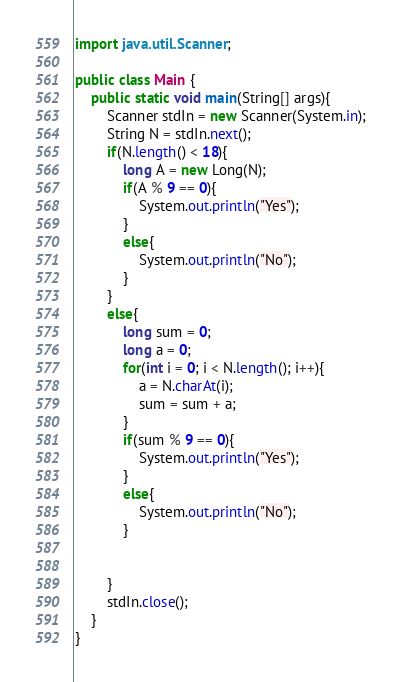Convert code to text. <code><loc_0><loc_0><loc_500><loc_500><_Java_>import java.util.Scanner;

public class Main {
	public static void main(String[] args){
		Scanner stdIn = new Scanner(System.in);
		String N = stdIn.next();
		if(N.length() < 18){
			long A = new Long(N);
			if(A % 9 == 0){
				System.out.println("Yes");
			}
			else{
				System.out.println("No");
			}
		}
		else{
			long sum = 0;
			long a = 0;
			for(int i = 0; i < N.length(); i++){
				a = N.charAt(i);
				sum = sum + a;
			}
			if(sum % 9 == 0){
				System.out.println("Yes");
			}
			else{
				System.out.println("No");
			}


		}
		stdIn.close();
	}
}
</code> 